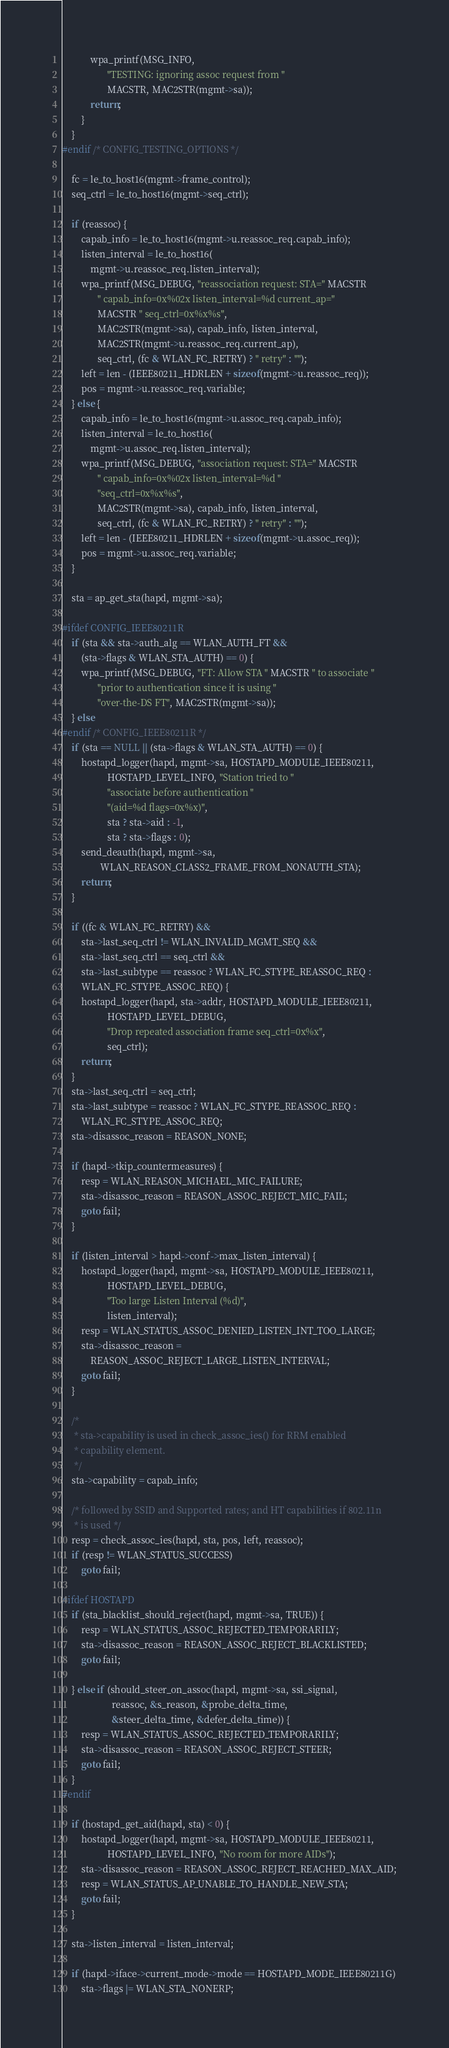Convert code to text. <code><loc_0><loc_0><loc_500><loc_500><_C_>			wpa_printf(MSG_INFO,
				   "TESTING: ignoring assoc request from "
				   MACSTR, MAC2STR(mgmt->sa));
			return;
		}
	}
#endif /* CONFIG_TESTING_OPTIONS */

	fc = le_to_host16(mgmt->frame_control);
	seq_ctrl = le_to_host16(mgmt->seq_ctrl);

	if (reassoc) {
		capab_info = le_to_host16(mgmt->u.reassoc_req.capab_info);
		listen_interval = le_to_host16(
			mgmt->u.reassoc_req.listen_interval);
		wpa_printf(MSG_DEBUG, "reassociation request: STA=" MACSTR
			   " capab_info=0x%02x listen_interval=%d current_ap="
			   MACSTR " seq_ctrl=0x%x%s",
			   MAC2STR(mgmt->sa), capab_info, listen_interval,
			   MAC2STR(mgmt->u.reassoc_req.current_ap),
			   seq_ctrl, (fc & WLAN_FC_RETRY) ? " retry" : "");
		left = len - (IEEE80211_HDRLEN + sizeof(mgmt->u.reassoc_req));
		pos = mgmt->u.reassoc_req.variable;
	} else {
		capab_info = le_to_host16(mgmt->u.assoc_req.capab_info);
		listen_interval = le_to_host16(
			mgmt->u.assoc_req.listen_interval);
		wpa_printf(MSG_DEBUG, "association request: STA=" MACSTR
			   " capab_info=0x%02x listen_interval=%d "
			   "seq_ctrl=0x%x%s",
			   MAC2STR(mgmt->sa), capab_info, listen_interval,
			   seq_ctrl, (fc & WLAN_FC_RETRY) ? " retry" : "");
		left = len - (IEEE80211_HDRLEN + sizeof(mgmt->u.assoc_req));
		pos = mgmt->u.assoc_req.variable;
	}

	sta = ap_get_sta(hapd, mgmt->sa);

#ifdef CONFIG_IEEE80211R
	if (sta && sta->auth_alg == WLAN_AUTH_FT &&
	    (sta->flags & WLAN_STA_AUTH) == 0) {
		wpa_printf(MSG_DEBUG, "FT: Allow STA " MACSTR " to associate "
			   "prior to authentication since it is using "
			   "over-the-DS FT", MAC2STR(mgmt->sa));
	} else
#endif /* CONFIG_IEEE80211R */
	if (sta == NULL || (sta->flags & WLAN_STA_AUTH) == 0) {
		hostapd_logger(hapd, mgmt->sa, HOSTAPD_MODULE_IEEE80211,
			       HOSTAPD_LEVEL_INFO, "Station tried to "
			       "associate before authentication "
			       "(aid=%d flags=0x%x)",
			       sta ? sta->aid : -1,
			       sta ? sta->flags : 0);
		send_deauth(hapd, mgmt->sa,
			    WLAN_REASON_CLASS2_FRAME_FROM_NONAUTH_STA);
		return;
	}

	if ((fc & WLAN_FC_RETRY) &&
	    sta->last_seq_ctrl != WLAN_INVALID_MGMT_SEQ &&
	    sta->last_seq_ctrl == seq_ctrl &&
	    sta->last_subtype == reassoc ? WLAN_FC_STYPE_REASSOC_REQ :
	    WLAN_FC_STYPE_ASSOC_REQ) {
		hostapd_logger(hapd, sta->addr, HOSTAPD_MODULE_IEEE80211,
			       HOSTAPD_LEVEL_DEBUG,
			       "Drop repeated association frame seq_ctrl=0x%x",
			       seq_ctrl);
		return;
	}
	sta->last_seq_ctrl = seq_ctrl;
	sta->last_subtype = reassoc ? WLAN_FC_STYPE_REASSOC_REQ :
		WLAN_FC_STYPE_ASSOC_REQ;
	sta->disassoc_reason = REASON_NONE;

	if (hapd->tkip_countermeasures) {
		resp = WLAN_REASON_MICHAEL_MIC_FAILURE;
		sta->disassoc_reason = REASON_ASSOC_REJECT_MIC_FAIL;
		goto fail;
	}

	if (listen_interval > hapd->conf->max_listen_interval) {
		hostapd_logger(hapd, mgmt->sa, HOSTAPD_MODULE_IEEE80211,
			       HOSTAPD_LEVEL_DEBUG,
			       "Too large Listen Interval (%d)",
			       listen_interval);
		resp = WLAN_STATUS_ASSOC_DENIED_LISTEN_INT_TOO_LARGE;
		sta->disassoc_reason =
			REASON_ASSOC_REJECT_LARGE_LISTEN_INTERVAL;
		goto fail;
	}

	/*
	 * sta->capability is used in check_assoc_ies() for RRM enabled
	 * capability element.
	 */
	sta->capability = capab_info;

	/* followed by SSID and Supported rates; and HT capabilities if 802.11n
	 * is used */
	resp = check_assoc_ies(hapd, sta, pos, left, reassoc);
	if (resp != WLAN_STATUS_SUCCESS)
		goto fail;

#ifdef HOSTAPD
	if (sta_blacklist_should_reject(hapd, mgmt->sa, TRUE)) {
		resp = WLAN_STATUS_ASSOC_REJECTED_TEMPORARILY;
		sta->disassoc_reason = REASON_ASSOC_REJECT_BLACKLISTED;
		goto fail;

	} else if (should_steer_on_assoc(hapd, mgmt->sa, ssi_signal,
					 reassoc, &s_reason, &probe_delta_time,
					 &steer_delta_time, &defer_delta_time)) {
		resp = WLAN_STATUS_ASSOC_REJECTED_TEMPORARILY;
		sta->disassoc_reason = REASON_ASSOC_REJECT_STEER;
		goto fail;
	}
#endif

	if (hostapd_get_aid(hapd, sta) < 0) {
		hostapd_logger(hapd, mgmt->sa, HOSTAPD_MODULE_IEEE80211,
			       HOSTAPD_LEVEL_INFO, "No room for more AIDs");
		sta->disassoc_reason = REASON_ASSOC_REJECT_REACHED_MAX_AID;
		resp = WLAN_STATUS_AP_UNABLE_TO_HANDLE_NEW_STA;
		goto fail;
	}

	sta->listen_interval = listen_interval;

	if (hapd->iface->current_mode->mode == HOSTAPD_MODE_IEEE80211G)
		sta->flags |= WLAN_STA_NONERP;</code> 